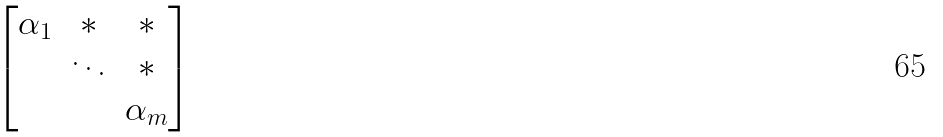Convert formula to latex. <formula><loc_0><loc_0><loc_500><loc_500>\begin{bmatrix} \alpha _ { 1 } & * & * \\ & \ddots & * \\ & & \alpha _ { m } \end{bmatrix}</formula> 